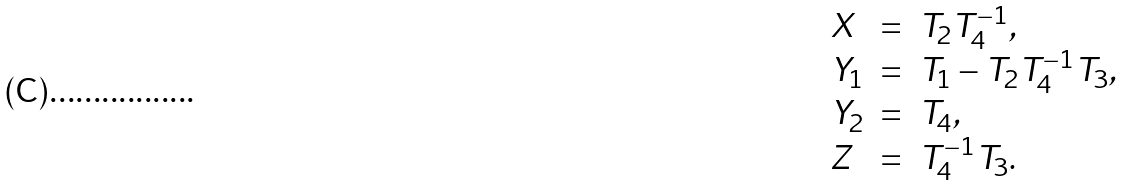Convert formula to latex. <formula><loc_0><loc_0><loc_500><loc_500>\begin{array} { l c l } X & = & T _ { 2 } T _ { 4 } ^ { - 1 } , \\ Y _ { 1 } & = & T _ { 1 } - T _ { 2 } T _ { 4 } ^ { - 1 } T _ { 3 } , \\ Y _ { 2 } & = & T _ { 4 } , \\ Z & = & T _ { 4 } ^ { - 1 } T _ { 3 } . \end{array}</formula> 